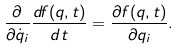<formula> <loc_0><loc_0><loc_500><loc_500>\frac { \partial } { \partial \dot { q } _ { i } } \frac { d f ( q , t ) } { d t } = \frac { \partial f ( q , t ) } { \partial q _ { i } } .</formula> 